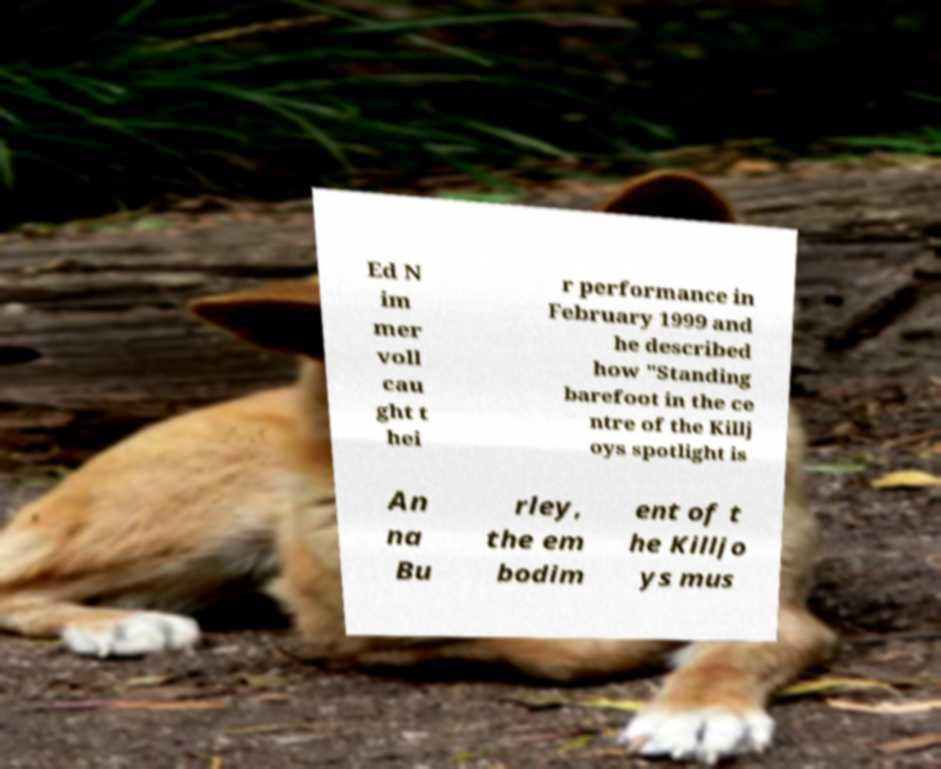Can you read and provide the text displayed in the image?This photo seems to have some interesting text. Can you extract and type it out for me? Ed N im mer voll cau ght t hei r performance in February 1999 and he described how "Standing barefoot in the ce ntre of the Killj oys spotlight is An na Bu rley, the em bodim ent of t he Killjo ys mus 